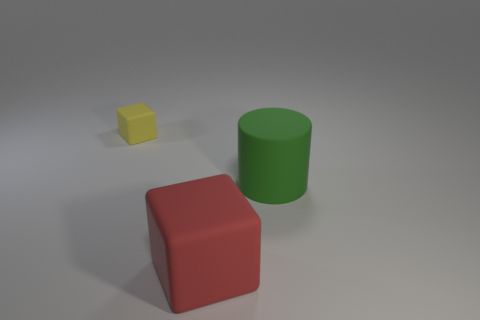The thing that is both behind the large red block and on the right side of the yellow object has what shape?
Ensure brevity in your answer.  Cylinder. There is a object on the left side of the red rubber object; is there a small yellow matte block to the right of it?
Your response must be concise. No. How many other things are made of the same material as the small thing?
Your response must be concise. 2. There is a rubber object in front of the green matte cylinder; does it have the same shape as the big rubber thing that is to the right of the big red block?
Provide a short and direct response. No. Do the yellow cube and the big cylinder have the same material?
Ensure brevity in your answer.  Yes. What is the size of the matte cube that is in front of the matte cube behind the rubber cube right of the tiny yellow cube?
Provide a succinct answer. Large. There is a red rubber object that is the same size as the green thing; what shape is it?
Your answer should be compact. Cube. What number of tiny objects are red matte cubes or green rubber things?
Offer a terse response. 0. Is there a green rubber object that is in front of the block in front of the rubber block that is to the left of the big cube?
Give a very brief answer. No. Is there a green cylinder of the same size as the yellow matte cube?
Ensure brevity in your answer.  No. 